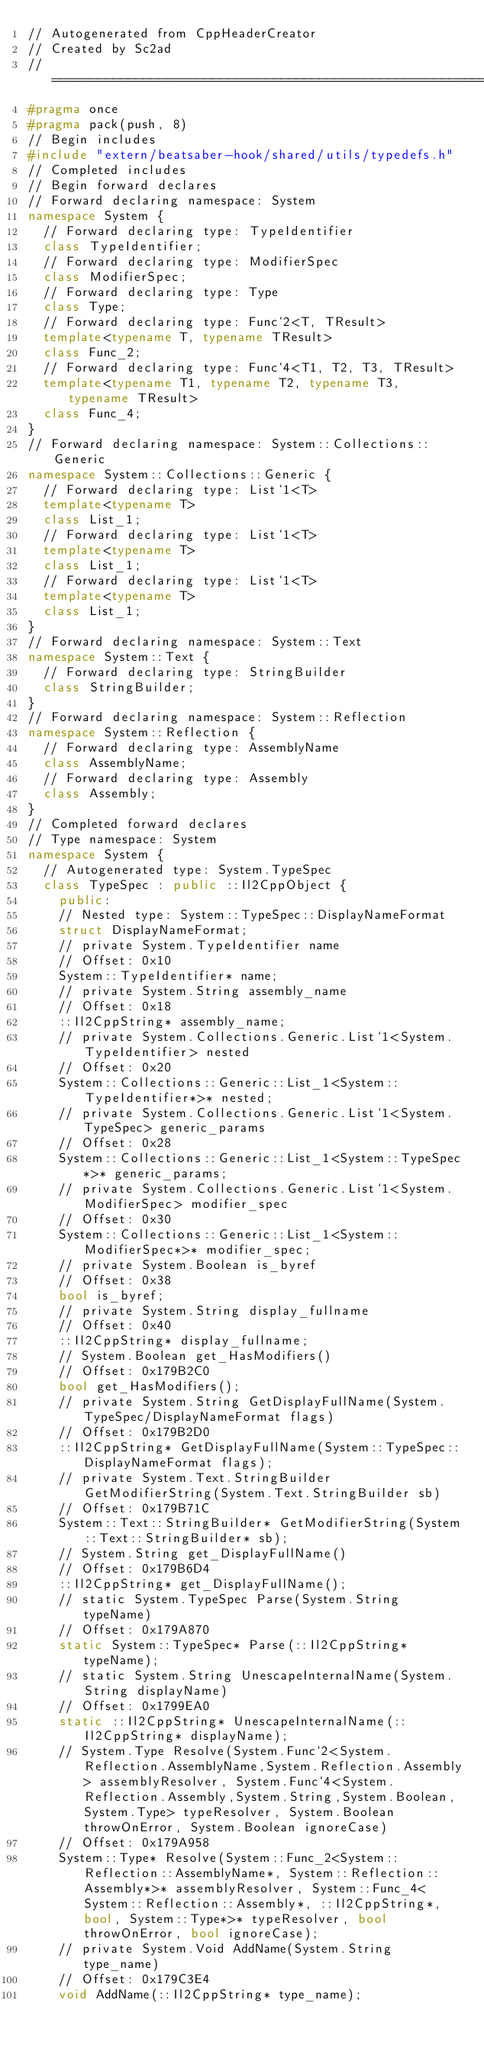Convert code to text. <code><loc_0><loc_0><loc_500><loc_500><_C++_>// Autogenerated from CppHeaderCreator
// Created by Sc2ad
// =========================================================================
#pragma once
#pragma pack(push, 8)
// Begin includes
#include "extern/beatsaber-hook/shared/utils/typedefs.h"
// Completed includes
// Begin forward declares
// Forward declaring namespace: System
namespace System {
  // Forward declaring type: TypeIdentifier
  class TypeIdentifier;
  // Forward declaring type: ModifierSpec
  class ModifierSpec;
  // Forward declaring type: Type
  class Type;
  // Forward declaring type: Func`2<T, TResult>
  template<typename T, typename TResult>
  class Func_2;
  // Forward declaring type: Func`4<T1, T2, T3, TResult>
  template<typename T1, typename T2, typename T3, typename TResult>
  class Func_4;
}
// Forward declaring namespace: System::Collections::Generic
namespace System::Collections::Generic {
  // Forward declaring type: List`1<T>
  template<typename T>
  class List_1;
  // Forward declaring type: List`1<T>
  template<typename T>
  class List_1;
  // Forward declaring type: List`1<T>
  template<typename T>
  class List_1;
}
// Forward declaring namespace: System::Text
namespace System::Text {
  // Forward declaring type: StringBuilder
  class StringBuilder;
}
// Forward declaring namespace: System::Reflection
namespace System::Reflection {
  // Forward declaring type: AssemblyName
  class AssemblyName;
  // Forward declaring type: Assembly
  class Assembly;
}
// Completed forward declares
// Type namespace: System
namespace System {
  // Autogenerated type: System.TypeSpec
  class TypeSpec : public ::Il2CppObject {
    public:
    // Nested type: System::TypeSpec::DisplayNameFormat
    struct DisplayNameFormat;
    // private System.TypeIdentifier name
    // Offset: 0x10
    System::TypeIdentifier* name;
    // private System.String assembly_name
    // Offset: 0x18
    ::Il2CppString* assembly_name;
    // private System.Collections.Generic.List`1<System.TypeIdentifier> nested
    // Offset: 0x20
    System::Collections::Generic::List_1<System::TypeIdentifier*>* nested;
    // private System.Collections.Generic.List`1<System.TypeSpec> generic_params
    // Offset: 0x28
    System::Collections::Generic::List_1<System::TypeSpec*>* generic_params;
    // private System.Collections.Generic.List`1<System.ModifierSpec> modifier_spec
    // Offset: 0x30
    System::Collections::Generic::List_1<System::ModifierSpec*>* modifier_spec;
    // private System.Boolean is_byref
    // Offset: 0x38
    bool is_byref;
    // private System.String display_fullname
    // Offset: 0x40
    ::Il2CppString* display_fullname;
    // System.Boolean get_HasModifiers()
    // Offset: 0x179B2C0
    bool get_HasModifiers();
    // private System.String GetDisplayFullName(System.TypeSpec/DisplayNameFormat flags)
    // Offset: 0x179B2D0
    ::Il2CppString* GetDisplayFullName(System::TypeSpec::DisplayNameFormat flags);
    // private System.Text.StringBuilder GetModifierString(System.Text.StringBuilder sb)
    // Offset: 0x179B71C
    System::Text::StringBuilder* GetModifierString(System::Text::StringBuilder* sb);
    // System.String get_DisplayFullName()
    // Offset: 0x179B6D4
    ::Il2CppString* get_DisplayFullName();
    // static System.TypeSpec Parse(System.String typeName)
    // Offset: 0x179A870
    static System::TypeSpec* Parse(::Il2CppString* typeName);
    // static System.String UnescapeInternalName(System.String displayName)
    // Offset: 0x1799EA0
    static ::Il2CppString* UnescapeInternalName(::Il2CppString* displayName);
    // System.Type Resolve(System.Func`2<System.Reflection.AssemblyName,System.Reflection.Assembly> assemblyResolver, System.Func`4<System.Reflection.Assembly,System.String,System.Boolean,System.Type> typeResolver, System.Boolean throwOnError, System.Boolean ignoreCase)
    // Offset: 0x179A958
    System::Type* Resolve(System::Func_2<System::Reflection::AssemblyName*, System::Reflection::Assembly*>* assemblyResolver, System::Func_4<System::Reflection::Assembly*, ::Il2CppString*, bool, System::Type*>* typeResolver, bool throwOnError, bool ignoreCase);
    // private System.Void AddName(System.String type_name)
    // Offset: 0x179C3E4
    void AddName(::Il2CppString* type_name);</code> 